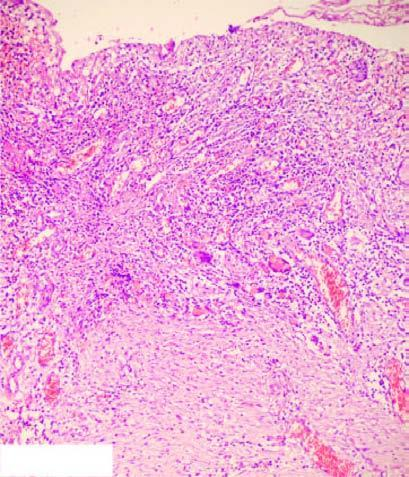where does the photomicrograph show necrotic debris, ulceration and inflammation on the mucosal surface?
Answer the question using a single word or phrase. On right 